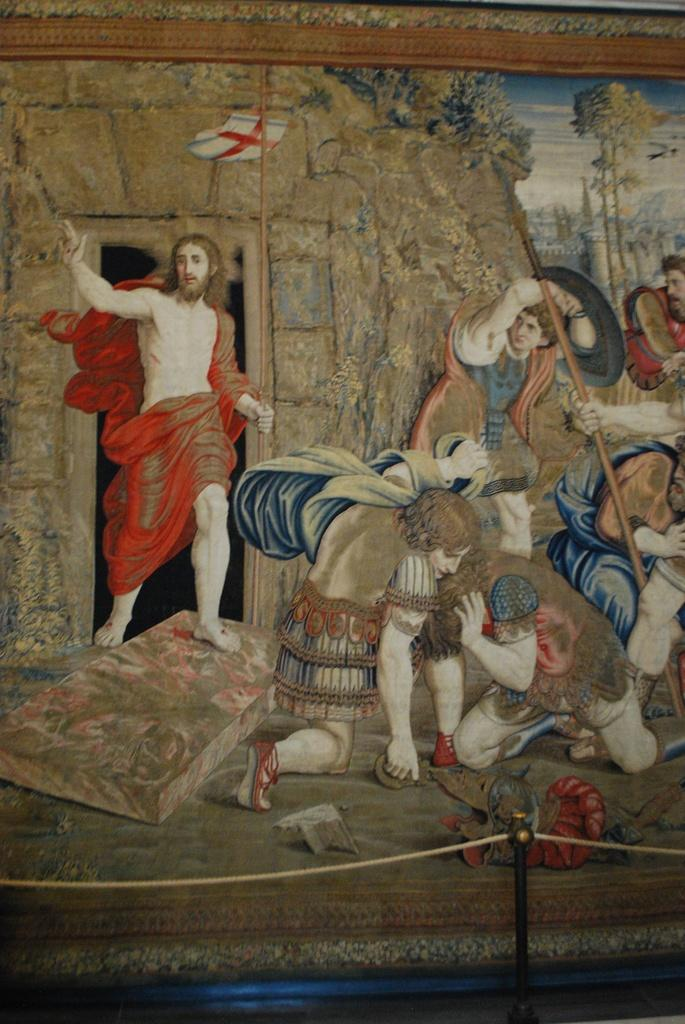Who or what can be seen in the image? There are people in the image. What type of natural elements are present in the image? There are trees in the image. What color is the flag visible in the image? There is a white-colored flag in the image. How many chairs can be seen in the image? There are no chairs visible in the image. What time is displayed on the watch in the image? There is no watch present in the image. 